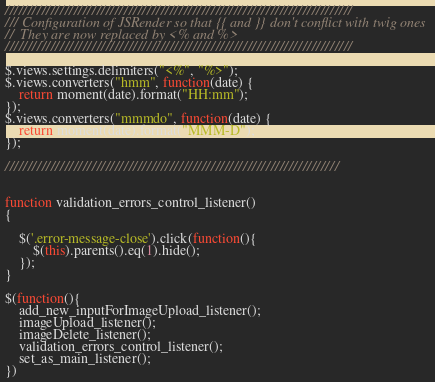<code> <loc_0><loc_0><loc_500><loc_500><_JavaScript_>////////////////////////////////////////////////////////////////////////////
/// Configuration of JSRender so that {{ and }} don't conflict with twig ones
//  They are now replaced by <% and %>
////////////////////////////////////////////////////////////////////////////

$.views.settings.delimiters("<%", "%>");
$.views.converters("hmm", function(date) {
    return moment(date).format("HH:mm");
});
$.views.converters("mmmdo", function(date) {
    return moment(date).format("MMM-D");
});

/////////////////////////////////////////////////////////////////////////


function validation_errors_control_listener()
{

    $('.error-message-close').click(function(){  
        $(this).parents().eq(1).hide();
    });
}

$(function(){
    add_new_inputForImageUpload_listener();
    imageUpload_listener();
    imageDelete_listener();
    validation_errors_control_listener();
    set_as_main_listener();
})
</code> 